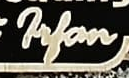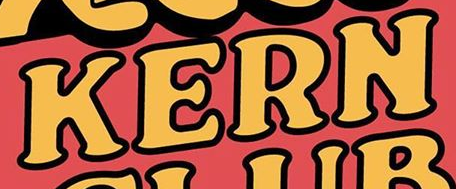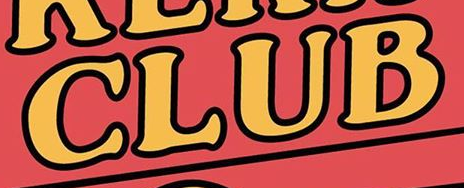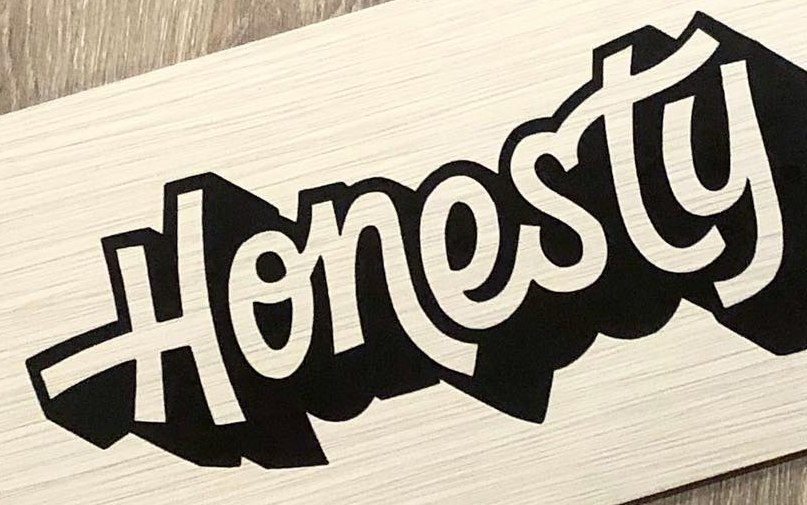What text appears in these images from left to right, separated by a semicolon? Filan; KERN; CLUB; Honesty 